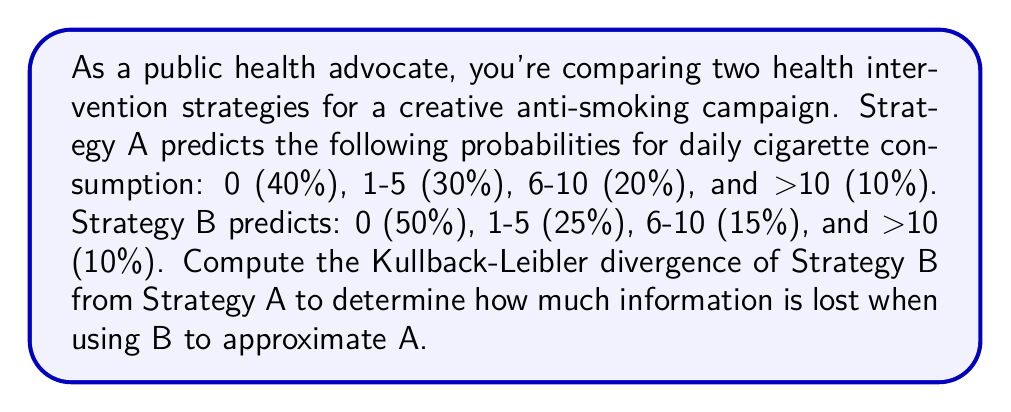Teach me how to tackle this problem. To compute the Kullback-Leibler (KL) divergence, we'll use the formula:

$$D_{KL}(A||B) = \sum_{i} A(i) \log\left(\frac{A(i)}{B(i)}\right)$$

Where $A(i)$ and $B(i)$ are the probabilities for each category in strategies A and B, respectively.

Let's calculate each term:

1. For 0 cigarettes:
   $0.4 \log\left(\frac{0.4}{0.5}\right) = 0.4 \log(0.8) = -0.0915$

2. For 1-5 cigarettes:
   $0.3 \log\left(\frac{0.3}{0.25}\right) = 0.3 \log(1.2) = 0.0547$

3. For 6-10 cigarettes:
   $0.2 \log\left(\frac{0.2}{0.15}\right) = 0.2 \log(1.3333) = 0.0577$

4. For >10 cigarettes:
   $0.1 \log\left(\frac{0.1}{0.1}\right) = 0.1 \log(1) = 0$

Now, sum all these terms:

$$D_{KL}(A||B) = -0.0915 + 0.0547 + 0.0577 + 0 = 0.0209$$

This value represents the information lost when using Strategy B to approximate Strategy A. A lower value indicates that the strategies are more similar in their predictions.
Answer: The Kullback-Leibler divergence of Strategy B from Strategy A is approximately 0.0209 bits. 